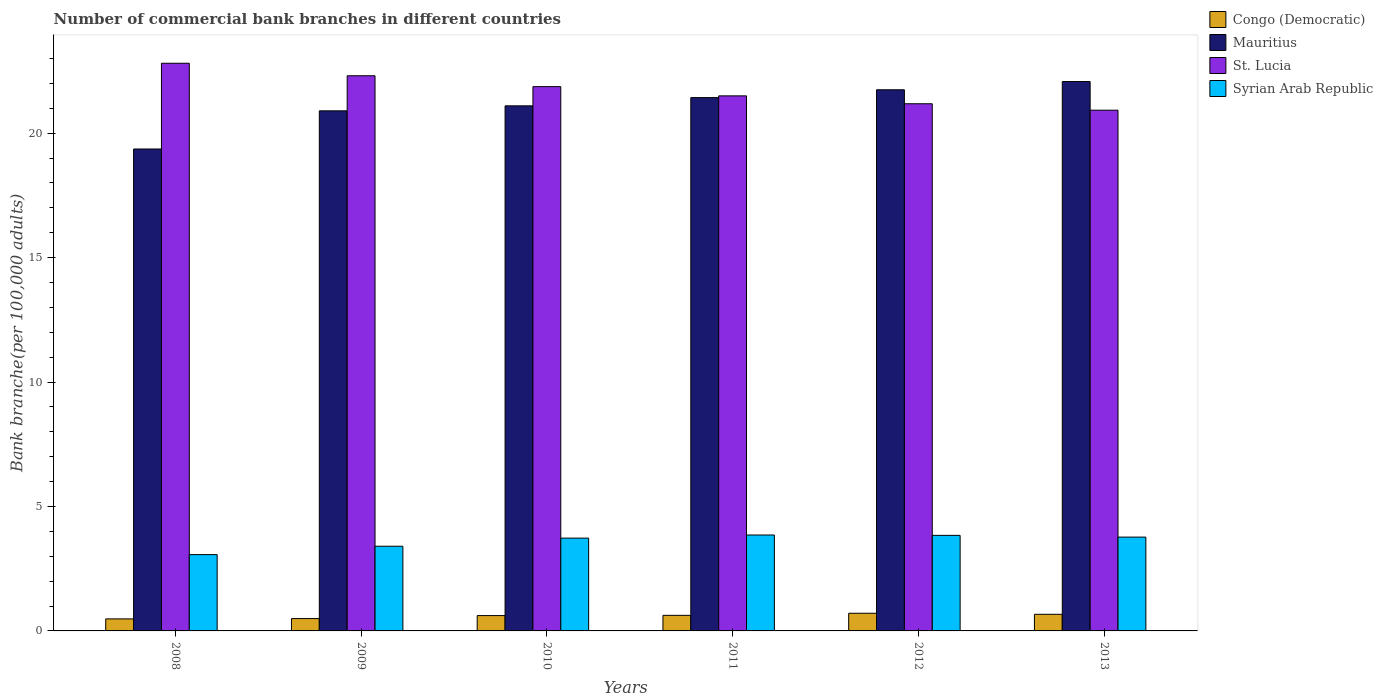How many different coloured bars are there?
Provide a short and direct response. 4. How many groups of bars are there?
Your answer should be very brief. 6. How many bars are there on the 1st tick from the right?
Keep it short and to the point. 4. What is the label of the 3rd group of bars from the left?
Your answer should be very brief. 2010. In how many cases, is the number of bars for a given year not equal to the number of legend labels?
Offer a terse response. 0. What is the number of commercial bank branches in St. Lucia in 2012?
Your response must be concise. 21.18. Across all years, what is the maximum number of commercial bank branches in Congo (Democratic)?
Provide a succinct answer. 0.71. Across all years, what is the minimum number of commercial bank branches in Syrian Arab Republic?
Provide a short and direct response. 3.07. In which year was the number of commercial bank branches in Congo (Democratic) minimum?
Provide a short and direct response. 2008. What is the total number of commercial bank branches in Congo (Democratic) in the graph?
Provide a succinct answer. 3.6. What is the difference between the number of commercial bank branches in Mauritius in 2008 and that in 2011?
Your answer should be compact. -2.06. What is the difference between the number of commercial bank branches in Syrian Arab Republic in 2008 and the number of commercial bank branches in St. Lucia in 2011?
Provide a succinct answer. -18.43. What is the average number of commercial bank branches in St. Lucia per year?
Your answer should be compact. 21.77. In the year 2010, what is the difference between the number of commercial bank branches in Mauritius and number of commercial bank branches in St. Lucia?
Ensure brevity in your answer.  -0.77. What is the ratio of the number of commercial bank branches in Syrian Arab Republic in 2008 to that in 2011?
Make the answer very short. 0.8. Is the number of commercial bank branches in Mauritius in 2009 less than that in 2010?
Make the answer very short. Yes. What is the difference between the highest and the second highest number of commercial bank branches in Congo (Democratic)?
Give a very brief answer. 0.04. What is the difference between the highest and the lowest number of commercial bank branches in Congo (Democratic)?
Provide a succinct answer. 0.23. In how many years, is the number of commercial bank branches in Syrian Arab Republic greater than the average number of commercial bank branches in Syrian Arab Republic taken over all years?
Offer a very short reply. 4. Is it the case that in every year, the sum of the number of commercial bank branches in Mauritius and number of commercial bank branches in Congo (Democratic) is greater than the sum of number of commercial bank branches in Syrian Arab Republic and number of commercial bank branches in St. Lucia?
Your answer should be very brief. No. What does the 1st bar from the left in 2012 represents?
Offer a very short reply. Congo (Democratic). What does the 4th bar from the right in 2009 represents?
Make the answer very short. Congo (Democratic). Is it the case that in every year, the sum of the number of commercial bank branches in Mauritius and number of commercial bank branches in Syrian Arab Republic is greater than the number of commercial bank branches in St. Lucia?
Your response must be concise. No. Are all the bars in the graph horizontal?
Provide a short and direct response. No. Does the graph contain any zero values?
Your response must be concise. No. Does the graph contain grids?
Your answer should be compact. No. Where does the legend appear in the graph?
Offer a very short reply. Top right. How many legend labels are there?
Keep it short and to the point. 4. What is the title of the graph?
Make the answer very short. Number of commercial bank branches in different countries. Does "Middle East & North Africa (all income levels)" appear as one of the legend labels in the graph?
Your response must be concise. No. What is the label or title of the X-axis?
Your answer should be compact. Years. What is the label or title of the Y-axis?
Make the answer very short. Bank branche(per 100,0 adults). What is the Bank branche(per 100,000 adults) of Congo (Democratic) in 2008?
Provide a short and direct response. 0.48. What is the Bank branche(per 100,000 adults) in Mauritius in 2008?
Make the answer very short. 19.36. What is the Bank branche(per 100,000 adults) in St. Lucia in 2008?
Ensure brevity in your answer.  22.81. What is the Bank branche(per 100,000 adults) of Syrian Arab Republic in 2008?
Provide a short and direct response. 3.07. What is the Bank branche(per 100,000 adults) of Congo (Democratic) in 2009?
Your response must be concise. 0.5. What is the Bank branche(per 100,000 adults) in Mauritius in 2009?
Your response must be concise. 20.9. What is the Bank branche(per 100,000 adults) in St. Lucia in 2009?
Ensure brevity in your answer.  22.31. What is the Bank branche(per 100,000 adults) in Syrian Arab Republic in 2009?
Give a very brief answer. 3.4. What is the Bank branche(per 100,000 adults) of Congo (Democratic) in 2010?
Your answer should be very brief. 0.62. What is the Bank branche(per 100,000 adults) in Mauritius in 2010?
Make the answer very short. 21.1. What is the Bank branche(per 100,000 adults) of St. Lucia in 2010?
Provide a succinct answer. 21.87. What is the Bank branche(per 100,000 adults) in Syrian Arab Republic in 2010?
Make the answer very short. 3.73. What is the Bank branche(per 100,000 adults) of Congo (Democratic) in 2011?
Keep it short and to the point. 0.63. What is the Bank branche(per 100,000 adults) of Mauritius in 2011?
Your answer should be compact. 21.43. What is the Bank branche(per 100,000 adults) in St. Lucia in 2011?
Keep it short and to the point. 21.5. What is the Bank branche(per 100,000 adults) in Syrian Arab Republic in 2011?
Provide a short and direct response. 3.85. What is the Bank branche(per 100,000 adults) in Congo (Democratic) in 2012?
Offer a terse response. 0.71. What is the Bank branche(per 100,000 adults) of Mauritius in 2012?
Ensure brevity in your answer.  21.74. What is the Bank branche(per 100,000 adults) of St. Lucia in 2012?
Your response must be concise. 21.18. What is the Bank branche(per 100,000 adults) of Syrian Arab Republic in 2012?
Provide a short and direct response. 3.84. What is the Bank branche(per 100,000 adults) in Congo (Democratic) in 2013?
Offer a terse response. 0.67. What is the Bank branche(per 100,000 adults) in Mauritius in 2013?
Provide a succinct answer. 22.08. What is the Bank branche(per 100,000 adults) in St. Lucia in 2013?
Ensure brevity in your answer.  20.92. What is the Bank branche(per 100,000 adults) in Syrian Arab Republic in 2013?
Ensure brevity in your answer.  3.77. Across all years, what is the maximum Bank branche(per 100,000 adults) in Congo (Democratic)?
Your response must be concise. 0.71. Across all years, what is the maximum Bank branche(per 100,000 adults) of Mauritius?
Offer a very short reply. 22.08. Across all years, what is the maximum Bank branche(per 100,000 adults) in St. Lucia?
Ensure brevity in your answer.  22.81. Across all years, what is the maximum Bank branche(per 100,000 adults) in Syrian Arab Republic?
Give a very brief answer. 3.85. Across all years, what is the minimum Bank branche(per 100,000 adults) of Congo (Democratic)?
Provide a short and direct response. 0.48. Across all years, what is the minimum Bank branche(per 100,000 adults) in Mauritius?
Your response must be concise. 19.36. Across all years, what is the minimum Bank branche(per 100,000 adults) in St. Lucia?
Give a very brief answer. 20.92. Across all years, what is the minimum Bank branche(per 100,000 adults) in Syrian Arab Republic?
Ensure brevity in your answer.  3.07. What is the total Bank branche(per 100,000 adults) of Congo (Democratic) in the graph?
Your response must be concise. 3.6. What is the total Bank branche(per 100,000 adults) of Mauritius in the graph?
Ensure brevity in your answer.  126.61. What is the total Bank branche(per 100,000 adults) of St. Lucia in the graph?
Make the answer very short. 130.59. What is the total Bank branche(per 100,000 adults) in Syrian Arab Republic in the graph?
Give a very brief answer. 21.66. What is the difference between the Bank branche(per 100,000 adults) of Congo (Democratic) in 2008 and that in 2009?
Make the answer very short. -0.01. What is the difference between the Bank branche(per 100,000 adults) of Mauritius in 2008 and that in 2009?
Ensure brevity in your answer.  -1.53. What is the difference between the Bank branche(per 100,000 adults) of St. Lucia in 2008 and that in 2009?
Provide a succinct answer. 0.5. What is the difference between the Bank branche(per 100,000 adults) in Syrian Arab Republic in 2008 and that in 2009?
Your answer should be very brief. -0.34. What is the difference between the Bank branche(per 100,000 adults) of Congo (Democratic) in 2008 and that in 2010?
Give a very brief answer. -0.13. What is the difference between the Bank branche(per 100,000 adults) of Mauritius in 2008 and that in 2010?
Your answer should be compact. -1.73. What is the difference between the Bank branche(per 100,000 adults) of St. Lucia in 2008 and that in 2010?
Offer a very short reply. 0.94. What is the difference between the Bank branche(per 100,000 adults) in Syrian Arab Republic in 2008 and that in 2010?
Your response must be concise. -0.66. What is the difference between the Bank branche(per 100,000 adults) of Congo (Democratic) in 2008 and that in 2011?
Keep it short and to the point. -0.14. What is the difference between the Bank branche(per 100,000 adults) of Mauritius in 2008 and that in 2011?
Provide a succinct answer. -2.06. What is the difference between the Bank branche(per 100,000 adults) in St. Lucia in 2008 and that in 2011?
Your answer should be compact. 1.31. What is the difference between the Bank branche(per 100,000 adults) of Syrian Arab Republic in 2008 and that in 2011?
Provide a succinct answer. -0.79. What is the difference between the Bank branche(per 100,000 adults) of Congo (Democratic) in 2008 and that in 2012?
Offer a very short reply. -0.23. What is the difference between the Bank branche(per 100,000 adults) in Mauritius in 2008 and that in 2012?
Your answer should be very brief. -2.38. What is the difference between the Bank branche(per 100,000 adults) in St. Lucia in 2008 and that in 2012?
Make the answer very short. 1.63. What is the difference between the Bank branche(per 100,000 adults) in Syrian Arab Republic in 2008 and that in 2012?
Provide a short and direct response. -0.77. What is the difference between the Bank branche(per 100,000 adults) of Congo (Democratic) in 2008 and that in 2013?
Keep it short and to the point. -0.19. What is the difference between the Bank branche(per 100,000 adults) of Mauritius in 2008 and that in 2013?
Give a very brief answer. -2.71. What is the difference between the Bank branche(per 100,000 adults) in St. Lucia in 2008 and that in 2013?
Your answer should be very brief. 1.89. What is the difference between the Bank branche(per 100,000 adults) in Syrian Arab Republic in 2008 and that in 2013?
Your response must be concise. -0.7. What is the difference between the Bank branche(per 100,000 adults) of Congo (Democratic) in 2009 and that in 2010?
Ensure brevity in your answer.  -0.12. What is the difference between the Bank branche(per 100,000 adults) of Mauritius in 2009 and that in 2010?
Your answer should be very brief. -0.2. What is the difference between the Bank branche(per 100,000 adults) of St. Lucia in 2009 and that in 2010?
Provide a succinct answer. 0.44. What is the difference between the Bank branche(per 100,000 adults) of Syrian Arab Republic in 2009 and that in 2010?
Provide a succinct answer. -0.33. What is the difference between the Bank branche(per 100,000 adults) in Congo (Democratic) in 2009 and that in 2011?
Make the answer very short. -0.13. What is the difference between the Bank branche(per 100,000 adults) of Mauritius in 2009 and that in 2011?
Make the answer very short. -0.53. What is the difference between the Bank branche(per 100,000 adults) of St. Lucia in 2009 and that in 2011?
Your answer should be very brief. 0.81. What is the difference between the Bank branche(per 100,000 adults) of Syrian Arab Republic in 2009 and that in 2011?
Offer a very short reply. -0.45. What is the difference between the Bank branche(per 100,000 adults) of Congo (Democratic) in 2009 and that in 2012?
Your answer should be very brief. -0.21. What is the difference between the Bank branche(per 100,000 adults) in Mauritius in 2009 and that in 2012?
Offer a terse response. -0.85. What is the difference between the Bank branche(per 100,000 adults) in St. Lucia in 2009 and that in 2012?
Your answer should be compact. 1.13. What is the difference between the Bank branche(per 100,000 adults) of Syrian Arab Republic in 2009 and that in 2012?
Offer a terse response. -0.44. What is the difference between the Bank branche(per 100,000 adults) in Congo (Democratic) in 2009 and that in 2013?
Offer a very short reply. -0.17. What is the difference between the Bank branche(per 100,000 adults) in Mauritius in 2009 and that in 2013?
Give a very brief answer. -1.18. What is the difference between the Bank branche(per 100,000 adults) of St. Lucia in 2009 and that in 2013?
Provide a succinct answer. 1.38. What is the difference between the Bank branche(per 100,000 adults) in Syrian Arab Republic in 2009 and that in 2013?
Ensure brevity in your answer.  -0.37. What is the difference between the Bank branche(per 100,000 adults) of Congo (Democratic) in 2010 and that in 2011?
Give a very brief answer. -0.01. What is the difference between the Bank branche(per 100,000 adults) in Mauritius in 2010 and that in 2011?
Your response must be concise. -0.33. What is the difference between the Bank branche(per 100,000 adults) in St. Lucia in 2010 and that in 2011?
Your response must be concise. 0.37. What is the difference between the Bank branche(per 100,000 adults) of Syrian Arab Republic in 2010 and that in 2011?
Your response must be concise. -0.12. What is the difference between the Bank branche(per 100,000 adults) of Congo (Democratic) in 2010 and that in 2012?
Offer a very short reply. -0.09. What is the difference between the Bank branche(per 100,000 adults) of Mauritius in 2010 and that in 2012?
Keep it short and to the point. -0.65. What is the difference between the Bank branche(per 100,000 adults) of St. Lucia in 2010 and that in 2012?
Ensure brevity in your answer.  0.69. What is the difference between the Bank branche(per 100,000 adults) of Syrian Arab Republic in 2010 and that in 2012?
Your answer should be very brief. -0.11. What is the difference between the Bank branche(per 100,000 adults) of Congo (Democratic) in 2010 and that in 2013?
Keep it short and to the point. -0.05. What is the difference between the Bank branche(per 100,000 adults) of Mauritius in 2010 and that in 2013?
Give a very brief answer. -0.98. What is the difference between the Bank branche(per 100,000 adults) of St. Lucia in 2010 and that in 2013?
Offer a terse response. 0.95. What is the difference between the Bank branche(per 100,000 adults) of Syrian Arab Republic in 2010 and that in 2013?
Provide a short and direct response. -0.04. What is the difference between the Bank branche(per 100,000 adults) in Congo (Democratic) in 2011 and that in 2012?
Your answer should be very brief. -0.08. What is the difference between the Bank branche(per 100,000 adults) in Mauritius in 2011 and that in 2012?
Provide a succinct answer. -0.32. What is the difference between the Bank branche(per 100,000 adults) in St. Lucia in 2011 and that in 2012?
Give a very brief answer. 0.32. What is the difference between the Bank branche(per 100,000 adults) of Syrian Arab Republic in 2011 and that in 2012?
Your answer should be very brief. 0.01. What is the difference between the Bank branche(per 100,000 adults) of Congo (Democratic) in 2011 and that in 2013?
Your answer should be compact. -0.04. What is the difference between the Bank branche(per 100,000 adults) of Mauritius in 2011 and that in 2013?
Ensure brevity in your answer.  -0.65. What is the difference between the Bank branche(per 100,000 adults) in St. Lucia in 2011 and that in 2013?
Provide a succinct answer. 0.58. What is the difference between the Bank branche(per 100,000 adults) in Syrian Arab Republic in 2011 and that in 2013?
Offer a terse response. 0.08. What is the difference between the Bank branche(per 100,000 adults) of Congo (Democratic) in 2012 and that in 2013?
Offer a very short reply. 0.04. What is the difference between the Bank branche(per 100,000 adults) of Mauritius in 2012 and that in 2013?
Your answer should be very brief. -0.33. What is the difference between the Bank branche(per 100,000 adults) in St. Lucia in 2012 and that in 2013?
Your answer should be very brief. 0.26. What is the difference between the Bank branche(per 100,000 adults) of Syrian Arab Republic in 2012 and that in 2013?
Make the answer very short. 0.07. What is the difference between the Bank branche(per 100,000 adults) in Congo (Democratic) in 2008 and the Bank branche(per 100,000 adults) in Mauritius in 2009?
Your answer should be very brief. -20.41. What is the difference between the Bank branche(per 100,000 adults) of Congo (Democratic) in 2008 and the Bank branche(per 100,000 adults) of St. Lucia in 2009?
Your answer should be compact. -21.82. What is the difference between the Bank branche(per 100,000 adults) of Congo (Democratic) in 2008 and the Bank branche(per 100,000 adults) of Syrian Arab Republic in 2009?
Make the answer very short. -2.92. What is the difference between the Bank branche(per 100,000 adults) in Mauritius in 2008 and the Bank branche(per 100,000 adults) in St. Lucia in 2009?
Ensure brevity in your answer.  -2.94. What is the difference between the Bank branche(per 100,000 adults) in Mauritius in 2008 and the Bank branche(per 100,000 adults) in Syrian Arab Republic in 2009?
Your answer should be compact. 15.96. What is the difference between the Bank branche(per 100,000 adults) of St. Lucia in 2008 and the Bank branche(per 100,000 adults) of Syrian Arab Republic in 2009?
Offer a terse response. 19.41. What is the difference between the Bank branche(per 100,000 adults) of Congo (Democratic) in 2008 and the Bank branche(per 100,000 adults) of Mauritius in 2010?
Provide a succinct answer. -20.62. What is the difference between the Bank branche(per 100,000 adults) in Congo (Democratic) in 2008 and the Bank branche(per 100,000 adults) in St. Lucia in 2010?
Your answer should be very brief. -21.39. What is the difference between the Bank branche(per 100,000 adults) of Congo (Democratic) in 2008 and the Bank branche(per 100,000 adults) of Syrian Arab Republic in 2010?
Your response must be concise. -3.25. What is the difference between the Bank branche(per 100,000 adults) of Mauritius in 2008 and the Bank branche(per 100,000 adults) of St. Lucia in 2010?
Your response must be concise. -2.51. What is the difference between the Bank branche(per 100,000 adults) of Mauritius in 2008 and the Bank branche(per 100,000 adults) of Syrian Arab Republic in 2010?
Offer a terse response. 15.64. What is the difference between the Bank branche(per 100,000 adults) of St. Lucia in 2008 and the Bank branche(per 100,000 adults) of Syrian Arab Republic in 2010?
Give a very brief answer. 19.08. What is the difference between the Bank branche(per 100,000 adults) of Congo (Democratic) in 2008 and the Bank branche(per 100,000 adults) of Mauritius in 2011?
Offer a very short reply. -20.95. What is the difference between the Bank branche(per 100,000 adults) of Congo (Democratic) in 2008 and the Bank branche(per 100,000 adults) of St. Lucia in 2011?
Ensure brevity in your answer.  -21.02. What is the difference between the Bank branche(per 100,000 adults) of Congo (Democratic) in 2008 and the Bank branche(per 100,000 adults) of Syrian Arab Republic in 2011?
Offer a very short reply. -3.37. What is the difference between the Bank branche(per 100,000 adults) in Mauritius in 2008 and the Bank branche(per 100,000 adults) in St. Lucia in 2011?
Provide a short and direct response. -2.13. What is the difference between the Bank branche(per 100,000 adults) of Mauritius in 2008 and the Bank branche(per 100,000 adults) of Syrian Arab Republic in 2011?
Give a very brief answer. 15.51. What is the difference between the Bank branche(per 100,000 adults) of St. Lucia in 2008 and the Bank branche(per 100,000 adults) of Syrian Arab Republic in 2011?
Provide a short and direct response. 18.96. What is the difference between the Bank branche(per 100,000 adults) in Congo (Democratic) in 2008 and the Bank branche(per 100,000 adults) in Mauritius in 2012?
Make the answer very short. -21.26. What is the difference between the Bank branche(per 100,000 adults) in Congo (Democratic) in 2008 and the Bank branche(per 100,000 adults) in St. Lucia in 2012?
Make the answer very short. -20.7. What is the difference between the Bank branche(per 100,000 adults) in Congo (Democratic) in 2008 and the Bank branche(per 100,000 adults) in Syrian Arab Republic in 2012?
Offer a terse response. -3.36. What is the difference between the Bank branche(per 100,000 adults) of Mauritius in 2008 and the Bank branche(per 100,000 adults) of St. Lucia in 2012?
Your answer should be very brief. -1.82. What is the difference between the Bank branche(per 100,000 adults) of Mauritius in 2008 and the Bank branche(per 100,000 adults) of Syrian Arab Republic in 2012?
Ensure brevity in your answer.  15.53. What is the difference between the Bank branche(per 100,000 adults) in St. Lucia in 2008 and the Bank branche(per 100,000 adults) in Syrian Arab Republic in 2012?
Your response must be concise. 18.97. What is the difference between the Bank branche(per 100,000 adults) of Congo (Democratic) in 2008 and the Bank branche(per 100,000 adults) of Mauritius in 2013?
Ensure brevity in your answer.  -21.59. What is the difference between the Bank branche(per 100,000 adults) of Congo (Democratic) in 2008 and the Bank branche(per 100,000 adults) of St. Lucia in 2013?
Give a very brief answer. -20.44. What is the difference between the Bank branche(per 100,000 adults) in Congo (Democratic) in 2008 and the Bank branche(per 100,000 adults) in Syrian Arab Republic in 2013?
Provide a succinct answer. -3.29. What is the difference between the Bank branche(per 100,000 adults) of Mauritius in 2008 and the Bank branche(per 100,000 adults) of St. Lucia in 2013?
Ensure brevity in your answer.  -1.56. What is the difference between the Bank branche(per 100,000 adults) of Mauritius in 2008 and the Bank branche(per 100,000 adults) of Syrian Arab Republic in 2013?
Keep it short and to the point. 15.6. What is the difference between the Bank branche(per 100,000 adults) of St. Lucia in 2008 and the Bank branche(per 100,000 adults) of Syrian Arab Republic in 2013?
Offer a very short reply. 19.04. What is the difference between the Bank branche(per 100,000 adults) in Congo (Democratic) in 2009 and the Bank branche(per 100,000 adults) in Mauritius in 2010?
Your answer should be compact. -20.6. What is the difference between the Bank branche(per 100,000 adults) of Congo (Democratic) in 2009 and the Bank branche(per 100,000 adults) of St. Lucia in 2010?
Your response must be concise. -21.38. What is the difference between the Bank branche(per 100,000 adults) in Congo (Democratic) in 2009 and the Bank branche(per 100,000 adults) in Syrian Arab Republic in 2010?
Ensure brevity in your answer.  -3.23. What is the difference between the Bank branche(per 100,000 adults) of Mauritius in 2009 and the Bank branche(per 100,000 adults) of St. Lucia in 2010?
Your answer should be compact. -0.97. What is the difference between the Bank branche(per 100,000 adults) of Mauritius in 2009 and the Bank branche(per 100,000 adults) of Syrian Arab Republic in 2010?
Keep it short and to the point. 17.17. What is the difference between the Bank branche(per 100,000 adults) in St. Lucia in 2009 and the Bank branche(per 100,000 adults) in Syrian Arab Republic in 2010?
Ensure brevity in your answer.  18.58. What is the difference between the Bank branche(per 100,000 adults) of Congo (Democratic) in 2009 and the Bank branche(per 100,000 adults) of Mauritius in 2011?
Your response must be concise. -20.93. What is the difference between the Bank branche(per 100,000 adults) in Congo (Democratic) in 2009 and the Bank branche(per 100,000 adults) in St. Lucia in 2011?
Keep it short and to the point. -21. What is the difference between the Bank branche(per 100,000 adults) of Congo (Democratic) in 2009 and the Bank branche(per 100,000 adults) of Syrian Arab Republic in 2011?
Your response must be concise. -3.36. What is the difference between the Bank branche(per 100,000 adults) in Mauritius in 2009 and the Bank branche(per 100,000 adults) in St. Lucia in 2011?
Offer a terse response. -0.6. What is the difference between the Bank branche(per 100,000 adults) in Mauritius in 2009 and the Bank branche(per 100,000 adults) in Syrian Arab Republic in 2011?
Your response must be concise. 17.04. What is the difference between the Bank branche(per 100,000 adults) in St. Lucia in 2009 and the Bank branche(per 100,000 adults) in Syrian Arab Republic in 2011?
Keep it short and to the point. 18.45. What is the difference between the Bank branche(per 100,000 adults) in Congo (Democratic) in 2009 and the Bank branche(per 100,000 adults) in Mauritius in 2012?
Offer a very short reply. -21.25. What is the difference between the Bank branche(per 100,000 adults) of Congo (Democratic) in 2009 and the Bank branche(per 100,000 adults) of St. Lucia in 2012?
Make the answer very short. -20.69. What is the difference between the Bank branche(per 100,000 adults) in Congo (Democratic) in 2009 and the Bank branche(per 100,000 adults) in Syrian Arab Republic in 2012?
Ensure brevity in your answer.  -3.34. What is the difference between the Bank branche(per 100,000 adults) in Mauritius in 2009 and the Bank branche(per 100,000 adults) in St. Lucia in 2012?
Offer a very short reply. -0.28. What is the difference between the Bank branche(per 100,000 adults) in Mauritius in 2009 and the Bank branche(per 100,000 adults) in Syrian Arab Republic in 2012?
Provide a short and direct response. 17.06. What is the difference between the Bank branche(per 100,000 adults) in St. Lucia in 2009 and the Bank branche(per 100,000 adults) in Syrian Arab Republic in 2012?
Provide a short and direct response. 18.47. What is the difference between the Bank branche(per 100,000 adults) in Congo (Democratic) in 2009 and the Bank branche(per 100,000 adults) in Mauritius in 2013?
Make the answer very short. -21.58. What is the difference between the Bank branche(per 100,000 adults) of Congo (Democratic) in 2009 and the Bank branche(per 100,000 adults) of St. Lucia in 2013?
Make the answer very short. -20.43. What is the difference between the Bank branche(per 100,000 adults) in Congo (Democratic) in 2009 and the Bank branche(per 100,000 adults) in Syrian Arab Republic in 2013?
Ensure brevity in your answer.  -3.27. What is the difference between the Bank branche(per 100,000 adults) of Mauritius in 2009 and the Bank branche(per 100,000 adults) of St. Lucia in 2013?
Provide a short and direct response. -0.03. What is the difference between the Bank branche(per 100,000 adults) of Mauritius in 2009 and the Bank branche(per 100,000 adults) of Syrian Arab Republic in 2013?
Your answer should be compact. 17.13. What is the difference between the Bank branche(per 100,000 adults) of St. Lucia in 2009 and the Bank branche(per 100,000 adults) of Syrian Arab Republic in 2013?
Make the answer very short. 18.54. What is the difference between the Bank branche(per 100,000 adults) of Congo (Democratic) in 2010 and the Bank branche(per 100,000 adults) of Mauritius in 2011?
Your answer should be compact. -20.81. What is the difference between the Bank branche(per 100,000 adults) of Congo (Democratic) in 2010 and the Bank branche(per 100,000 adults) of St. Lucia in 2011?
Make the answer very short. -20.88. What is the difference between the Bank branche(per 100,000 adults) in Congo (Democratic) in 2010 and the Bank branche(per 100,000 adults) in Syrian Arab Republic in 2011?
Your answer should be compact. -3.24. What is the difference between the Bank branche(per 100,000 adults) of Mauritius in 2010 and the Bank branche(per 100,000 adults) of St. Lucia in 2011?
Keep it short and to the point. -0.4. What is the difference between the Bank branche(per 100,000 adults) of Mauritius in 2010 and the Bank branche(per 100,000 adults) of Syrian Arab Republic in 2011?
Your response must be concise. 17.24. What is the difference between the Bank branche(per 100,000 adults) in St. Lucia in 2010 and the Bank branche(per 100,000 adults) in Syrian Arab Republic in 2011?
Your answer should be compact. 18.02. What is the difference between the Bank branche(per 100,000 adults) in Congo (Democratic) in 2010 and the Bank branche(per 100,000 adults) in Mauritius in 2012?
Give a very brief answer. -21.13. What is the difference between the Bank branche(per 100,000 adults) of Congo (Democratic) in 2010 and the Bank branche(per 100,000 adults) of St. Lucia in 2012?
Your answer should be very brief. -20.57. What is the difference between the Bank branche(per 100,000 adults) of Congo (Democratic) in 2010 and the Bank branche(per 100,000 adults) of Syrian Arab Republic in 2012?
Keep it short and to the point. -3.22. What is the difference between the Bank branche(per 100,000 adults) in Mauritius in 2010 and the Bank branche(per 100,000 adults) in St. Lucia in 2012?
Provide a succinct answer. -0.08. What is the difference between the Bank branche(per 100,000 adults) of Mauritius in 2010 and the Bank branche(per 100,000 adults) of Syrian Arab Republic in 2012?
Offer a very short reply. 17.26. What is the difference between the Bank branche(per 100,000 adults) of St. Lucia in 2010 and the Bank branche(per 100,000 adults) of Syrian Arab Republic in 2012?
Keep it short and to the point. 18.03. What is the difference between the Bank branche(per 100,000 adults) of Congo (Democratic) in 2010 and the Bank branche(per 100,000 adults) of Mauritius in 2013?
Offer a very short reply. -21.46. What is the difference between the Bank branche(per 100,000 adults) of Congo (Democratic) in 2010 and the Bank branche(per 100,000 adults) of St. Lucia in 2013?
Provide a short and direct response. -20.31. What is the difference between the Bank branche(per 100,000 adults) of Congo (Democratic) in 2010 and the Bank branche(per 100,000 adults) of Syrian Arab Republic in 2013?
Provide a succinct answer. -3.15. What is the difference between the Bank branche(per 100,000 adults) in Mauritius in 2010 and the Bank branche(per 100,000 adults) in St. Lucia in 2013?
Provide a short and direct response. 0.17. What is the difference between the Bank branche(per 100,000 adults) in Mauritius in 2010 and the Bank branche(per 100,000 adults) in Syrian Arab Republic in 2013?
Ensure brevity in your answer.  17.33. What is the difference between the Bank branche(per 100,000 adults) of St. Lucia in 2010 and the Bank branche(per 100,000 adults) of Syrian Arab Republic in 2013?
Keep it short and to the point. 18.1. What is the difference between the Bank branche(per 100,000 adults) in Congo (Democratic) in 2011 and the Bank branche(per 100,000 adults) in Mauritius in 2012?
Your answer should be very brief. -21.12. What is the difference between the Bank branche(per 100,000 adults) of Congo (Democratic) in 2011 and the Bank branche(per 100,000 adults) of St. Lucia in 2012?
Keep it short and to the point. -20.56. What is the difference between the Bank branche(per 100,000 adults) in Congo (Democratic) in 2011 and the Bank branche(per 100,000 adults) in Syrian Arab Republic in 2012?
Offer a terse response. -3.21. What is the difference between the Bank branche(per 100,000 adults) of Mauritius in 2011 and the Bank branche(per 100,000 adults) of St. Lucia in 2012?
Your answer should be compact. 0.25. What is the difference between the Bank branche(per 100,000 adults) of Mauritius in 2011 and the Bank branche(per 100,000 adults) of Syrian Arab Republic in 2012?
Provide a short and direct response. 17.59. What is the difference between the Bank branche(per 100,000 adults) in St. Lucia in 2011 and the Bank branche(per 100,000 adults) in Syrian Arab Republic in 2012?
Your answer should be compact. 17.66. What is the difference between the Bank branche(per 100,000 adults) in Congo (Democratic) in 2011 and the Bank branche(per 100,000 adults) in Mauritius in 2013?
Your response must be concise. -21.45. What is the difference between the Bank branche(per 100,000 adults) in Congo (Democratic) in 2011 and the Bank branche(per 100,000 adults) in St. Lucia in 2013?
Offer a terse response. -20.3. What is the difference between the Bank branche(per 100,000 adults) of Congo (Democratic) in 2011 and the Bank branche(per 100,000 adults) of Syrian Arab Republic in 2013?
Offer a terse response. -3.14. What is the difference between the Bank branche(per 100,000 adults) of Mauritius in 2011 and the Bank branche(per 100,000 adults) of St. Lucia in 2013?
Provide a short and direct response. 0.51. What is the difference between the Bank branche(per 100,000 adults) in Mauritius in 2011 and the Bank branche(per 100,000 adults) in Syrian Arab Republic in 2013?
Make the answer very short. 17.66. What is the difference between the Bank branche(per 100,000 adults) in St. Lucia in 2011 and the Bank branche(per 100,000 adults) in Syrian Arab Republic in 2013?
Offer a very short reply. 17.73. What is the difference between the Bank branche(per 100,000 adults) in Congo (Democratic) in 2012 and the Bank branche(per 100,000 adults) in Mauritius in 2013?
Your answer should be very brief. -21.37. What is the difference between the Bank branche(per 100,000 adults) of Congo (Democratic) in 2012 and the Bank branche(per 100,000 adults) of St. Lucia in 2013?
Your answer should be compact. -20.21. What is the difference between the Bank branche(per 100,000 adults) of Congo (Democratic) in 2012 and the Bank branche(per 100,000 adults) of Syrian Arab Republic in 2013?
Keep it short and to the point. -3.06. What is the difference between the Bank branche(per 100,000 adults) of Mauritius in 2012 and the Bank branche(per 100,000 adults) of St. Lucia in 2013?
Give a very brief answer. 0.82. What is the difference between the Bank branche(per 100,000 adults) in Mauritius in 2012 and the Bank branche(per 100,000 adults) in Syrian Arab Republic in 2013?
Provide a short and direct response. 17.98. What is the difference between the Bank branche(per 100,000 adults) of St. Lucia in 2012 and the Bank branche(per 100,000 adults) of Syrian Arab Republic in 2013?
Ensure brevity in your answer.  17.41. What is the average Bank branche(per 100,000 adults) in Congo (Democratic) per year?
Ensure brevity in your answer.  0.6. What is the average Bank branche(per 100,000 adults) in Mauritius per year?
Your response must be concise. 21.1. What is the average Bank branche(per 100,000 adults) of St. Lucia per year?
Your response must be concise. 21.77. What is the average Bank branche(per 100,000 adults) of Syrian Arab Republic per year?
Ensure brevity in your answer.  3.61. In the year 2008, what is the difference between the Bank branche(per 100,000 adults) of Congo (Democratic) and Bank branche(per 100,000 adults) of Mauritius?
Offer a very short reply. -18.88. In the year 2008, what is the difference between the Bank branche(per 100,000 adults) in Congo (Democratic) and Bank branche(per 100,000 adults) in St. Lucia?
Provide a short and direct response. -22.33. In the year 2008, what is the difference between the Bank branche(per 100,000 adults) in Congo (Democratic) and Bank branche(per 100,000 adults) in Syrian Arab Republic?
Your answer should be very brief. -2.58. In the year 2008, what is the difference between the Bank branche(per 100,000 adults) of Mauritius and Bank branche(per 100,000 adults) of St. Lucia?
Your answer should be very brief. -3.45. In the year 2008, what is the difference between the Bank branche(per 100,000 adults) of Mauritius and Bank branche(per 100,000 adults) of Syrian Arab Republic?
Ensure brevity in your answer.  16.3. In the year 2008, what is the difference between the Bank branche(per 100,000 adults) of St. Lucia and Bank branche(per 100,000 adults) of Syrian Arab Republic?
Your answer should be compact. 19.74. In the year 2009, what is the difference between the Bank branche(per 100,000 adults) of Congo (Democratic) and Bank branche(per 100,000 adults) of Mauritius?
Make the answer very short. -20.4. In the year 2009, what is the difference between the Bank branche(per 100,000 adults) in Congo (Democratic) and Bank branche(per 100,000 adults) in St. Lucia?
Ensure brevity in your answer.  -21.81. In the year 2009, what is the difference between the Bank branche(per 100,000 adults) in Congo (Democratic) and Bank branche(per 100,000 adults) in Syrian Arab Republic?
Offer a very short reply. -2.91. In the year 2009, what is the difference between the Bank branche(per 100,000 adults) of Mauritius and Bank branche(per 100,000 adults) of St. Lucia?
Your response must be concise. -1.41. In the year 2009, what is the difference between the Bank branche(per 100,000 adults) in Mauritius and Bank branche(per 100,000 adults) in Syrian Arab Republic?
Provide a short and direct response. 17.5. In the year 2009, what is the difference between the Bank branche(per 100,000 adults) in St. Lucia and Bank branche(per 100,000 adults) in Syrian Arab Republic?
Offer a terse response. 18.91. In the year 2010, what is the difference between the Bank branche(per 100,000 adults) in Congo (Democratic) and Bank branche(per 100,000 adults) in Mauritius?
Make the answer very short. -20.48. In the year 2010, what is the difference between the Bank branche(per 100,000 adults) of Congo (Democratic) and Bank branche(per 100,000 adults) of St. Lucia?
Your answer should be compact. -21.25. In the year 2010, what is the difference between the Bank branche(per 100,000 adults) in Congo (Democratic) and Bank branche(per 100,000 adults) in Syrian Arab Republic?
Give a very brief answer. -3.11. In the year 2010, what is the difference between the Bank branche(per 100,000 adults) in Mauritius and Bank branche(per 100,000 adults) in St. Lucia?
Your response must be concise. -0.77. In the year 2010, what is the difference between the Bank branche(per 100,000 adults) of Mauritius and Bank branche(per 100,000 adults) of Syrian Arab Republic?
Make the answer very short. 17.37. In the year 2010, what is the difference between the Bank branche(per 100,000 adults) in St. Lucia and Bank branche(per 100,000 adults) in Syrian Arab Republic?
Your answer should be very brief. 18.14. In the year 2011, what is the difference between the Bank branche(per 100,000 adults) of Congo (Democratic) and Bank branche(per 100,000 adults) of Mauritius?
Your answer should be very brief. -20.8. In the year 2011, what is the difference between the Bank branche(per 100,000 adults) in Congo (Democratic) and Bank branche(per 100,000 adults) in St. Lucia?
Give a very brief answer. -20.87. In the year 2011, what is the difference between the Bank branche(per 100,000 adults) in Congo (Democratic) and Bank branche(per 100,000 adults) in Syrian Arab Republic?
Offer a terse response. -3.23. In the year 2011, what is the difference between the Bank branche(per 100,000 adults) of Mauritius and Bank branche(per 100,000 adults) of St. Lucia?
Offer a very short reply. -0.07. In the year 2011, what is the difference between the Bank branche(per 100,000 adults) in Mauritius and Bank branche(per 100,000 adults) in Syrian Arab Republic?
Provide a short and direct response. 17.58. In the year 2011, what is the difference between the Bank branche(per 100,000 adults) in St. Lucia and Bank branche(per 100,000 adults) in Syrian Arab Republic?
Ensure brevity in your answer.  17.65. In the year 2012, what is the difference between the Bank branche(per 100,000 adults) in Congo (Democratic) and Bank branche(per 100,000 adults) in Mauritius?
Offer a terse response. -21.03. In the year 2012, what is the difference between the Bank branche(per 100,000 adults) of Congo (Democratic) and Bank branche(per 100,000 adults) of St. Lucia?
Your answer should be compact. -20.47. In the year 2012, what is the difference between the Bank branche(per 100,000 adults) in Congo (Democratic) and Bank branche(per 100,000 adults) in Syrian Arab Republic?
Offer a terse response. -3.13. In the year 2012, what is the difference between the Bank branche(per 100,000 adults) in Mauritius and Bank branche(per 100,000 adults) in St. Lucia?
Give a very brief answer. 0.56. In the year 2012, what is the difference between the Bank branche(per 100,000 adults) in Mauritius and Bank branche(per 100,000 adults) in Syrian Arab Republic?
Keep it short and to the point. 17.91. In the year 2012, what is the difference between the Bank branche(per 100,000 adults) in St. Lucia and Bank branche(per 100,000 adults) in Syrian Arab Republic?
Keep it short and to the point. 17.34. In the year 2013, what is the difference between the Bank branche(per 100,000 adults) in Congo (Democratic) and Bank branche(per 100,000 adults) in Mauritius?
Keep it short and to the point. -21.41. In the year 2013, what is the difference between the Bank branche(per 100,000 adults) in Congo (Democratic) and Bank branche(per 100,000 adults) in St. Lucia?
Your answer should be compact. -20.26. In the year 2013, what is the difference between the Bank branche(per 100,000 adults) of Congo (Democratic) and Bank branche(per 100,000 adults) of Syrian Arab Republic?
Your answer should be very brief. -3.1. In the year 2013, what is the difference between the Bank branche(per 100,000 adults) of Mauritius and Bank branche(per 100,000 adults) of St. Lucia?
Make the answer very short. 1.15. In the year 2013, what is the difference between the Bank branche(per 100,000 adults) in Mauritius and Bank branche(per 100,000 adults) in Syrian Arab Republic?
Your response must be concise. 18.31. In the year 2013, what is the difference between the Bank branche(per 100,000 adults) in St. Lucia and Bank branche(per 100,000 adults) in Syrian Arab Republic?
Your response must be concise. 17.15. What is the ratio of the Bank branche(per 100,000 adults) in Congo (Democratic) in 2008 to that in 2009?
Keep it short and to the point. 0.97. What is the ratio of the Bank branche(per 100,000 adults) in Mauritius in 2008 to that in 2009?
Ensure brevity in your answer.  0.93. What is the ratio of the Bank branche(per 100,000 adults) of St. Lucia in 2008 to that in 2009?
Your response must be concise. 1.02. What is the ratio of the Bank branche(per 100,000 adults) of Syrian Arab Republic in 2008 to that in 2009?
Offer a very short reply. 0.9. What is the ratio of the Bank branche(per 100,000 adults) in Congo (Democratic) in 2008 to that in 2010?
Your answer should be compact. 0.78. What is the ratio of the Bank branche(per 100,000 adults) of Mauritius in 2008 to that in 2010?
Offer a terse response. 0.92. What is the ratio of the Bank branche(per 100,000 adults) of St. Lucia in 2008 to that in 2010?
Keep it short and to the point. 1.04. What is the ratio of the Bank branche(per 100,000 adults) in Syrian Arab Republic in 2008 to that in 2010?
Give a very brief answer. 0.82. What is the ratio of the Bank branche(per 100,000 adults) of Congo (Democratic) in 2008 to that in 2011?
Give a very brief answer. 0.77. What is the ratio of the Bank branche(per 100,000 adults) in Mauritius in 2008 to that in 2011?
Provide a short and direct response. 0.9. What is the ratio of the Bank branche(per 100,000 adults) in St. Lucia in 2008 to that in 2011?
Your response must be concise. 1.06. What is the ratio of the Bank branche(per 100,000 adults) in Syrian Arab Republic in 2008 to that in 2011?
Make the answer very short. 0.8. What is the ratio of the Bank branche(per 100,000 adults) of Congo (Democratic) in 2008 to that in 2012?
Keep it short and to the point. 0.68. What is the ratio of the Bank branche(per 100,000 adults) in Mauritius in 2008 to that in 2012?
Your answer should be very brief. 0.89. What is the ratio of the Bank branche(per 100,000 adults) of St. Lucia in 2008 to that in 2012?
Offer a very short reply. 1.08. What is the ratio of the Bank branche(per 100,000 adults) of Syrian Arab Republic in 2008 to that in 2012?
Your response must be concise. 0.8. What is the ratio of the Bank branche(per 100,000 adults) in Congo (Democratic) in 2008 to that in 2013?
Provide a succinct answer. 0.72. What is the ratio of the Bank branche(per 100,000 adults) in Mauritius in 2008 to that in 2013?
Provide a succinct answer. 0.88. What is the ratio of the Bank branche(per 100,000 adults) in St. Lucia in 2008 to that in 2013?
Keep it short and to the point. 1.09. What is the ratio of the Bank branche(per 100,000 adults) of Syrian Arab Republic in 2008 to that in 2013?
Make the answer very short. 0.81. What is the ratio of the Bank branche(per 100,000 adults) in Congo (Democratic) in 2009 to that in 2010?
Give a very brief answer. 0.8. What is the ratio of the Bank branche(per 100,000 adults) in St. Lucia in 2009 to that in 2010?
Give a very brief answer. 1.02. What is the ratio of the Bank branche(per 100,000 adults) of Syrian Arab Republic in 2009 to that in 2010?
Make the answer very short. 0.91. What is the ratio of the Bank branche(per 100,000 adults) of Congo (Democratic) in 2009 to that in 2011?
Your answer should be compact. 0.79. What is the ratio of the Bank branche(per 100,000 adults) in Mauritius in 2009 to that in 2011?
Provide a succinct answer. 0.98. What is the ratio of the Bank branche(per 100,000 adults) of St. Lucia in 2009 to that in 2011?
Provide a short and direct response. 1.04. What is the ratio of the Bank branche(per 100,000 adults) in Syrian Arab Republic in 2009 to that in 2011?
Give a very brief answer. 0.88. What is the ratio of the Bank branche(per 100,000 adults) of Congo (Democratic) in 2009 to that in 2012?
Give a very brief answer. 0.7. What is the ratio of the Bank branche(per 100,000 adults) in Mauritius in 2009 to that in 2012?
Keep it short and to the point. 0.96. What is the ratio of the Bank branche(per 100,000 adults) in St. Lucia in 2009 to that in 2012?
Your response must be concise. 1.05. What is the ratio of the Bank branche(per 100,000 adults) in Syrian Arab Republic in 2009 to that in 2012?
Your answer should be very brief. 0.89. What is the ratio of the Bank branche(per 100,000 adults) in Congo (Democratic) in 2009 to that in 2013?
Your response must be concise. 0.74. What is the ratio of the Bank branche(per 100,000 adults) of Mauritius in 2009 to that in 2013?
Offer a very short reply. 0.95. What is the ratio of the Bank branche(per 100,000 adults) of St. Lucia in 2009 to that in 2013?
Your answer should be very brief. 1.07. What is the ratio of the Bank branche(per 100,000 adults) in Syrian Arab Republic in 2009 to that in 2013?
Keep it short and to the point. 0.9. What is the ratio of the Bank branche(per 100,000 adults) in Congo (Democratic) in 2010 to that in 2011?
Offer a terse response. 0.98. What is the ratio of the Bank branche(per 100,000 adults) of Mauritius in 2010 to that in 2011?
Ensure brevity in your answer.  0.98. What is the ratio of the Bank branche(per 100,000 adults) of St. Lucia in 2010 to that in 2011?
Keep it short and to the point. 1.02. What is the ratio of the Bank branche(per 100,000 adults) of Syrian Arab Republic in 2010 to that in 2011?
Your answer should be compact. 0.97. What is the ratio of the Bank branche(per 100,000 adults) in Congo (Democratic) in 2010 to that in 2012?
Provide a succinct answer. 0.87. What is the ratio of the Bank branche(per 100,000 adults) of Mauritius in 2010 to that in 2012?
Provide a succinct answer. 0.97. What is the ratio of the Bank branche(per 100,000 adults) in St. Lucia in 2010 to that in 2012?
Provide a succinct answer. 1.03. What is the ratio of the Bank branche(per 100,000 adults) in Syrian Arab Republic in 2010 to that in 2012?
Keep it short and to the point. 0.97. What is the ratio of the Bank branche(per 100,000 adults) of Congo (Democratic) in 2010 to that in 2013?
Your answer should be compact. 0.92. What is the ratio of the Bank branche(per 100,000 adults) in Mauritius in 2010 to that in 2013?
Your answer should be compact. 0.96. What is the ratio of the Bank branche(per 100,000 adults) of St. Lucia in 2010 to that in 2013?
Keep it short and to the point. 1.05. What is the ratio of the Bank branche(per 100,000 adults) in Syrian Arab Republic in 2010 to that in 2013?
Offer a terse response. 0.99. What is the ratio of the Bank branche(per 100,000 adults) of Congo (Democratic) in 2011 to that in 2012?
Your answer should be very brief. 0.88. What is the ratio of the Bank branche(per 100,000 adults) in Mauritius in 2011 to that in 2012?
Offer a very short reply. 0.99. What is the ratio of the Bank branche(per 100,000 adults) of Congo (Democratic) in 2011 to that in 2013?
Make the answer very short. 0.94. What is the ratio of the Bank branche(per 100,000 adults) of Mauritius in 2011 to that in 2013?
Your answer should be very brief. 0.97. What is the ratio of the Bank branche(per 100,000 adults) in St. Lucia in 2011 to that in 2013?
Make the answer very short. 1.03. What is the ratio of the Bank branche(per 100,000 adults) in Syrian Arab Republic in 2011 to that in 2013?
Offer a terse response. 1.02. What is the ratio of the Bank branche(per 100,000 adults) of Congo (Democratic) in 2012 to that in 2013?
Provide a short and direct response. 1.06. What is the ratio of the Bank branche(per 100,000 adults) in St. Lucia in 2012 to that in 2013?
Ensure brevity in your answer.  1.01. What is the ratio of the Bank branche(per 100,000 adults) of Syrian Arab Republic in 2012 to that in 2013?
Offer a terse response. 1.02. What is the difference between the highest and the second highest Bank branche(per 100,000 adults) of Congo (Democratic)?
Offer a terse response. 0.04. What is the difference between the highest and the second highest Bank branche(per 100,000 adults) of Mauritius?
Keep it short and to the point. 0.33. What is the difference between the highest and the second highest Bank branche(per 100,000 adults) of St. Lucia?
Make the answer very short. 0.5. What is the difference between the highest and the second highest Bank branche(per 100,000 adults) in Syrian Arab Republic?
Your response must be concise. 0.01. What is the difference between the highest and the lowest Bank branche(per 100,000 adults) of Congo (Democratic)?
Keep it short and to the point. 0.23. What is the difference between the highest and the lowest Bank branche(per 100,000 adults) of Mauritius?
Make the answer very short. 2.71. What is the difference between the highest and the lowest Bank branche(per 100,000 adults) of St. Lucia?
Provide a short and direct response. 1.89. What is the difference between the highest and the lowest Bank branche(per 100,000 adults) in Syrian Arab Republic?
Ensure brevity in your answer.  0.79. 